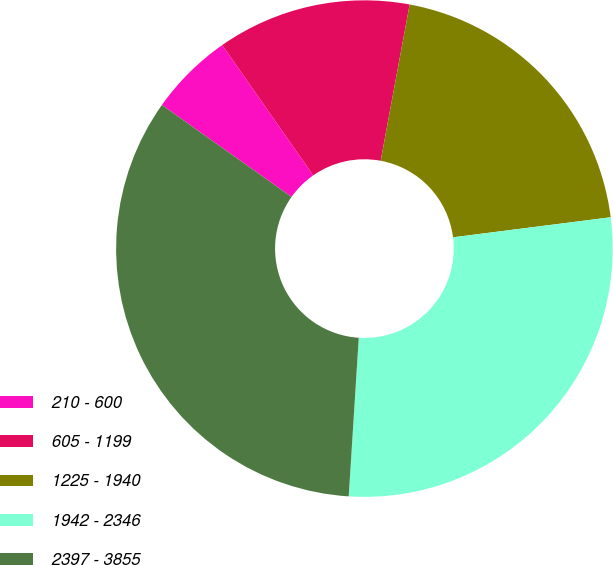Convert chart to OTSL. <chart><loc_0><loc_0><loc_500><loc_500><pie_chart><fcel>210 - 600<fcel>605 - 1199<fcel>1225 - 1940<fcel>1942 - 2346<fcel>2397 - 3855<nl><fcel>5.48%<fcel>12.62%<fcel>20.07%<fcel>28.02%<fcel>33.81%<nl></chart> 